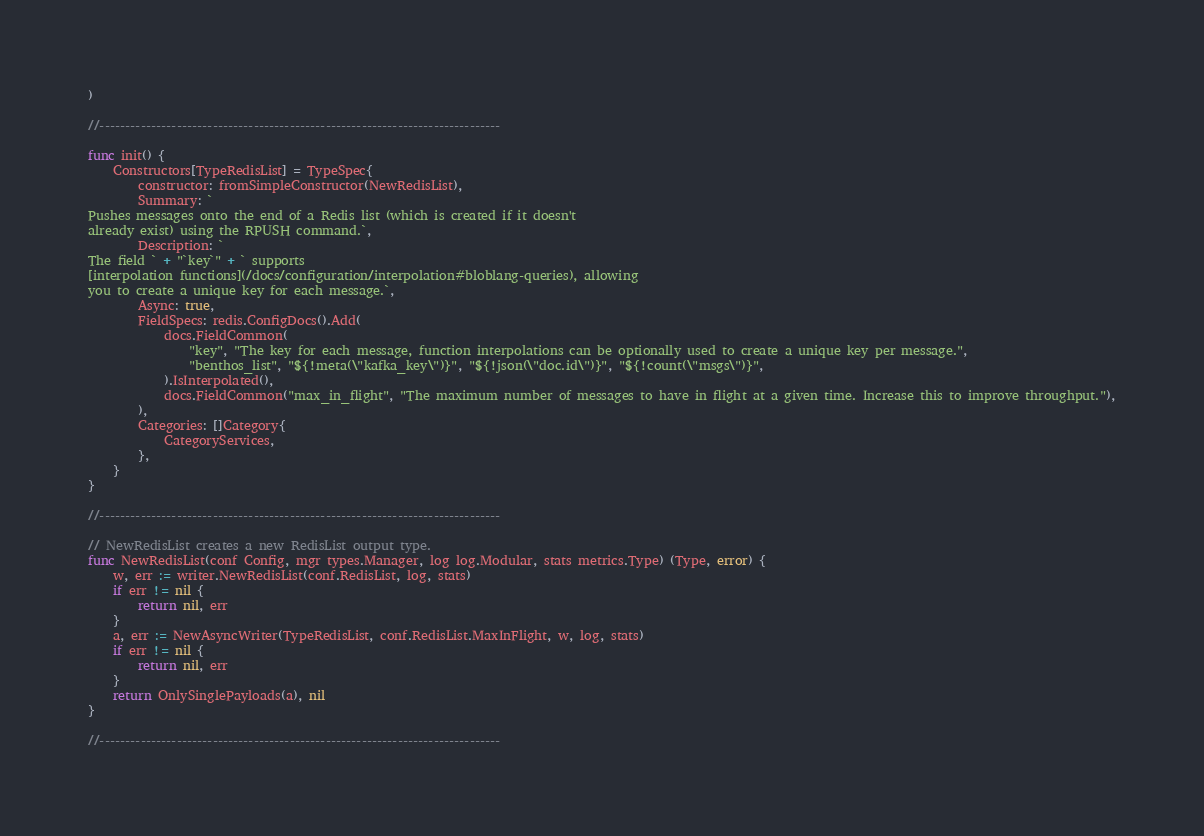Convert code to text. <code><loc_0><loc_0><loc_500><loc_500><_Go_>)

//------------------------------------------------------------------------------

func init() {
	Constructors[TypeRedisList] = TypeSpec{
		constructor: fromSimpleConstructor(NewRedisList),
		Summary: `
Pushes messages onto the end of a Redis list (which is created if it doesn't
already exist) using the RPUSH command.`,
		Description: `
The field ` + "`key`" + ` supports
[interpolation functions](/docs/configuration/interpolation#bloblang-queries), allowing
you to create a unique key for each message.`,
		Async: true,
		FieldSpecs: redis.ConfigDocs().Add(
			docs.FieldCommon(
				"key", "The key for each message, function interpolations can be optionally used to create a unique key per message.",
				"benthos_list", "${!meta(\"kafka_key\")}", "${!json(\"doc.id\")}", "${!count(\"msgs\")}",
			).IsInterpolated(),
			docs.FieldCommon("max_in_flight", "The maximum number of messages to have in flight at a given time. Increase this to improve throughput."),
		),
		Categories: []Category{
			CategoryServices,
		},
	}
}

//------------------------------------------------------------------------------

// NewRedisList creates a new RedisList output type.
func NewRedisList(conf Config, mgr types.Manager, log log.Modular, stats metrics.Type) (Type, error) {
	w, err := writer.NewRedisList(conf.RedisList, log, stats)
	if err != nil {
		return nil, err
	}
	a, err := NewAsyncWriter(TypeRedisList, conf.RedisList.MaxInFlight, w, log, stats)
	if err != nil {
		return nil, err
	}
	return OnlySinglePayloads(a), nil
}

//------------------------------------------------------------------------------
</code> 